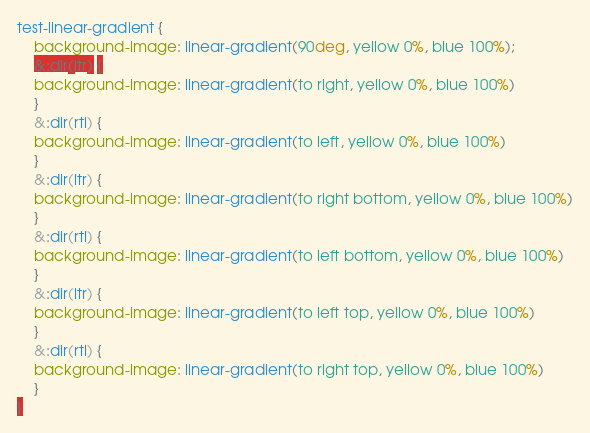Convert code to text. <code><loc_0><loc_0><loc_500><loc_500><_CSS_>test-linear-gradient {
	background-image: linear-gradient(90deg, yellow 0%, blue 100%);
	&:dir(ltr) {
	background-image: linear-gradient(to right, yellow 0%, blue 100%)
	}
	&:dir(rtl) {
	background-image: linear-gradient(to left, yellow 0%, blue 100%)
	}
	&:dir(ltr) {
	background-image: linear-gradient(to right bottom, yellow 0%, blue 100%)
	}
	&:dir(rtl) {
	background-image: linear-gradient(to left bottom, yellow 0%, blue 100%)
	}
	&:dir(ltr) {
	background-image: linear-gradient(to left top, yellow 0%, blue 100%)
	}
	&:dir(rtl) {
	background-image: linear-gradient(to right top, yellow 0%, blue 100%)
	}
}
</code> 